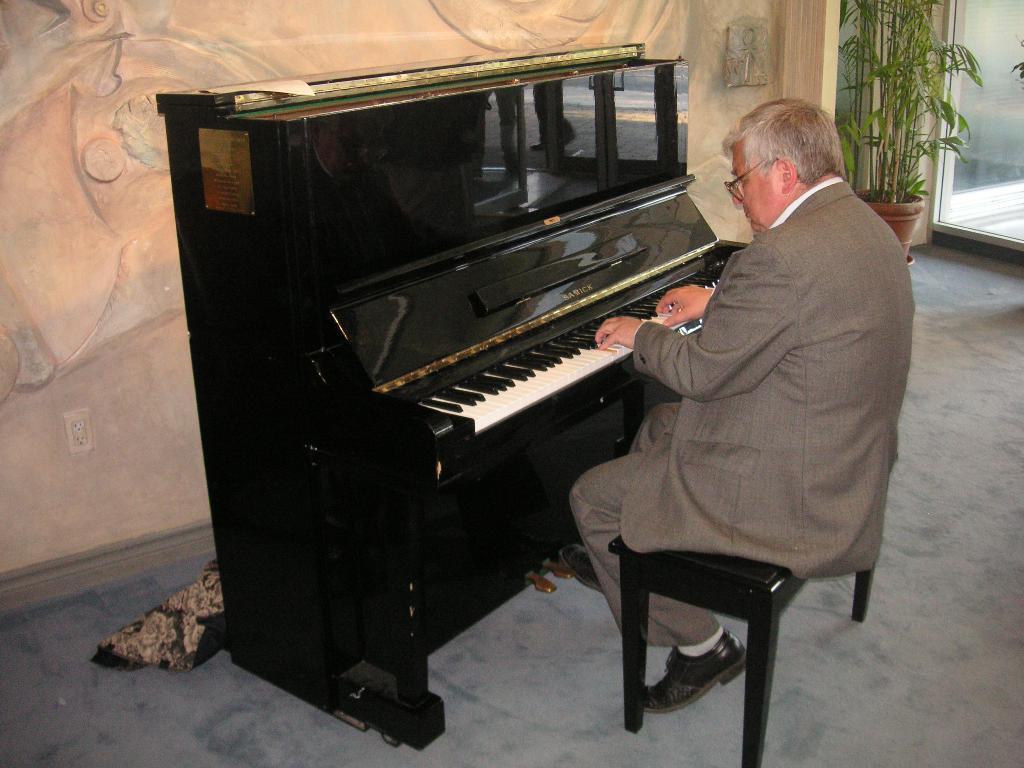Could you give a brief overview of what you see in this image? In this image I can see a person sitting on the bench and playing the piano. To the right there is a flower pot. In the background there is a wall. 